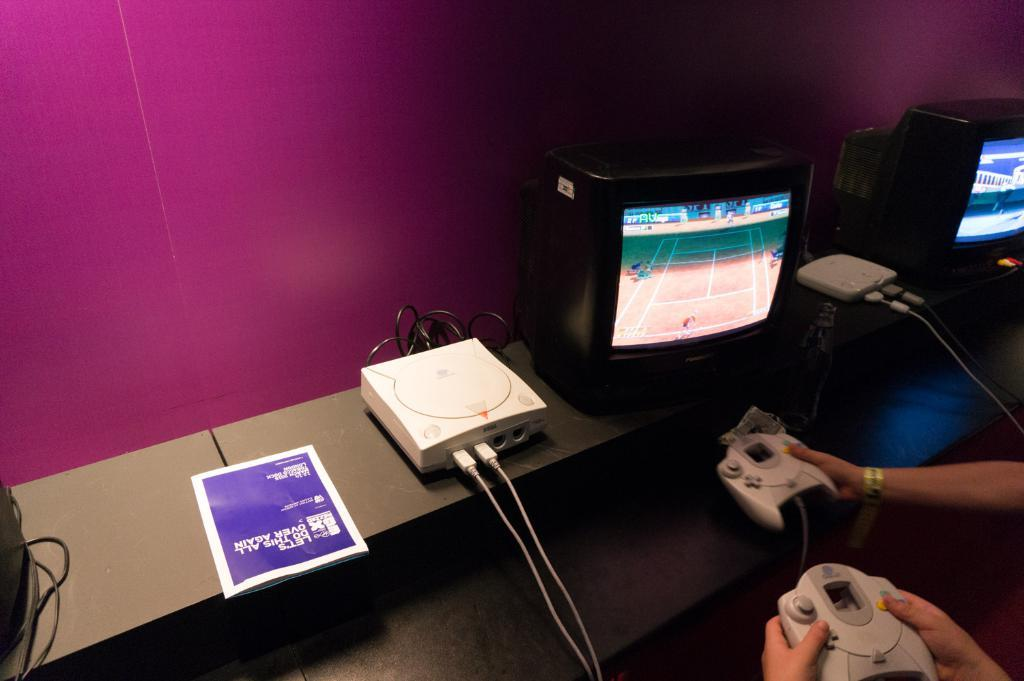<image>
Write a terse but informative summary of the picture. A person playing a game and a book on the table that says Let's do this all over again. 